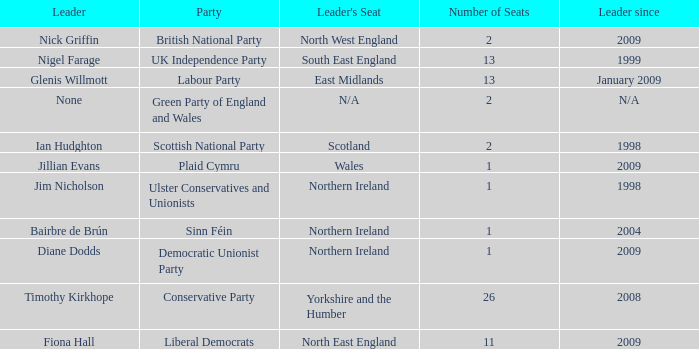Which party does Timothy Kirkhope lead? Conservative Party. Help me parse the entirety of this table. {'header': ['Leader', 'Party', "Leader's Seat", 'Number of Seats', 'Leader since'], 'rows': [['Nick Griffin', 'British National Party', 'North West England', '2', '2009'], ['Nigel Farage', 'UK Independence Party', 'South East England', '13', '1999'], ['Glenis Willmott', 'Labour Party', 'East Midlands', '13', 'January 2009'], ['None', 'Green Party of England and Wales', 'N/A', '2', 'N/A'], ['Ian Hudghton', 'Scottish National Party', 'Scotland', '2', '1998'], ['Jillian Evans', 'Plaid Cymru', 'Wales', '1', '2009'], ['Jim Nicholson', 'Ulster Conservatives and Unionists', 'Northern Ireland', '1', '1998'], ['Bairbre de Brún', 'Sinn Féin', 'Northern Ireland', '1', '2004'], ['Diane Dodds', 'Democratic Unionist Party', 'Northern Ireland', '1', '2009'], ['Timothy Kirkhope', 'Conservative Party', 'Yorkshire and the Humber', '26', '2008'], ['Fiona Hall', 'Liberal Democrats', 'North East England', '11', '2009']]} 